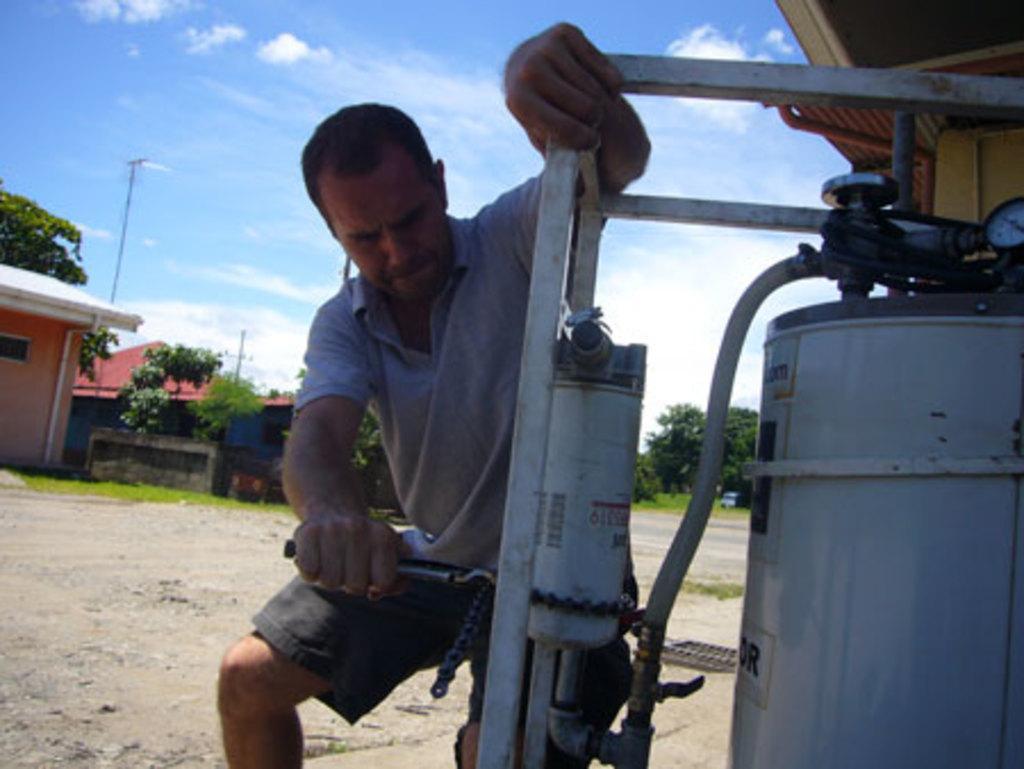Could you give a brief overview of what you see in this image? In this image a person is rearing some machine and at the back there are some trees and houses and the background is the sky. 